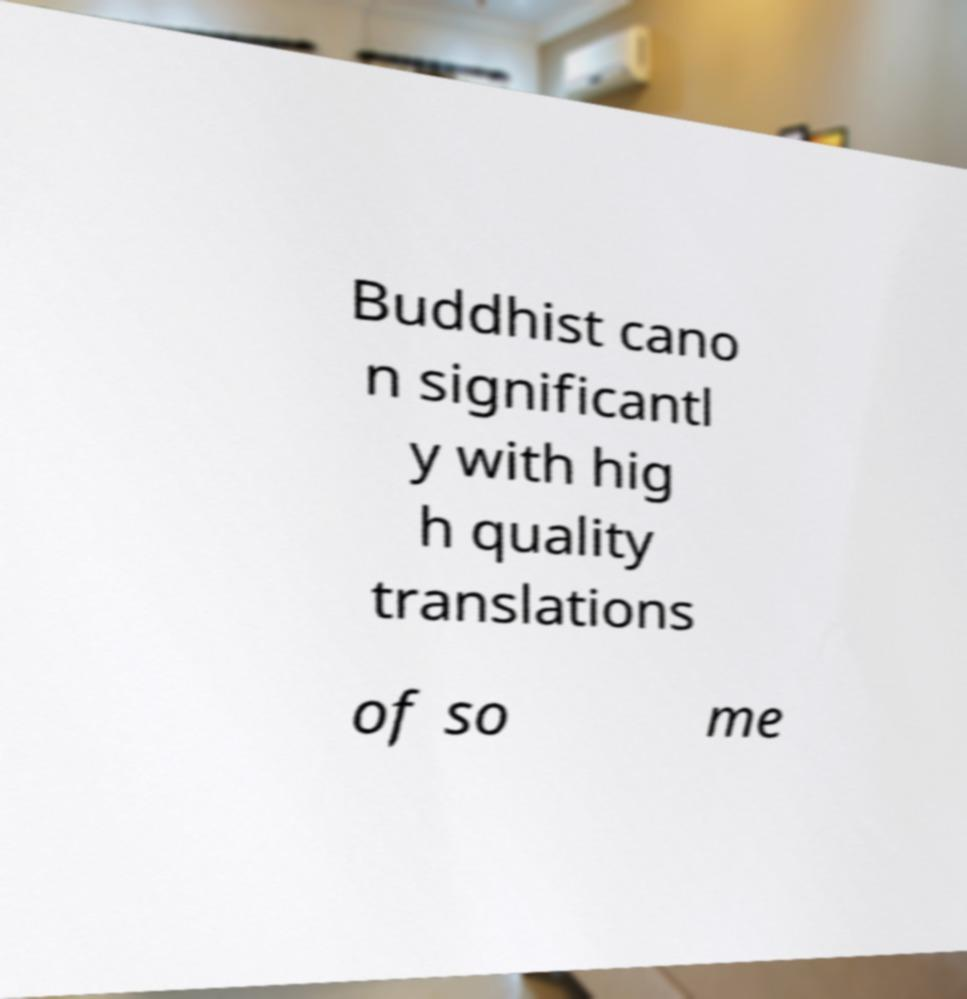Please identify and transcribe the text found in this image. Buddhist cano n significantl y with hig h quality translations of so me 